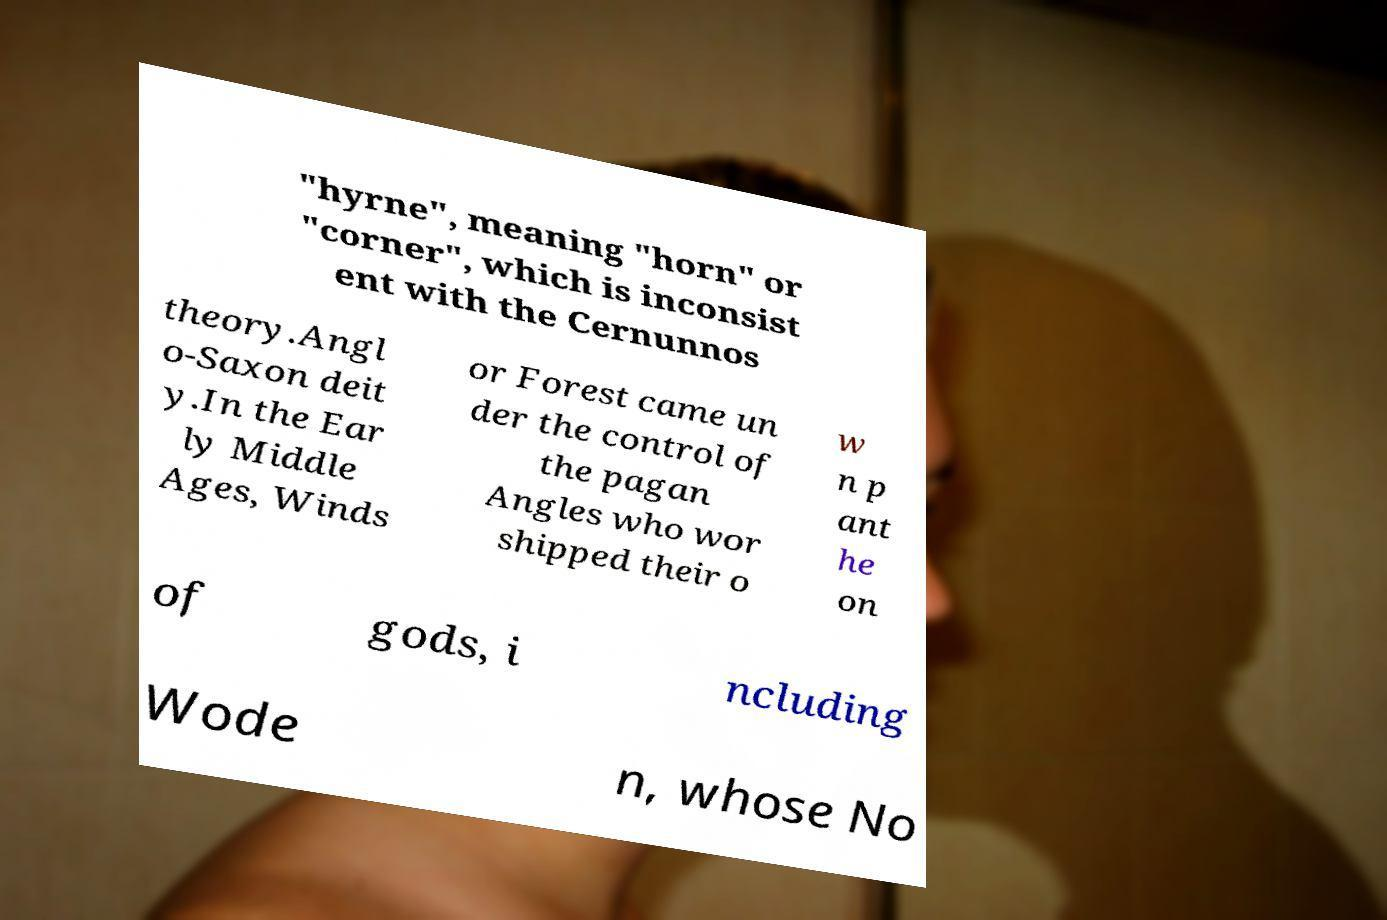Could you assist in decoding the text presented in this image and type it out clearly? "hyrne", meaning "horn" or "corner", which is inconsist ent with the Cernunnos theory.Angl o-Saxon deit y.In the Ear ly Middle Ages, Winds or Forest came un der the control of the pagan Angles who wor shipped their o w n p ant he on of gods, i ncluding Wode n, whose No 